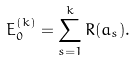<formula> <loc_0><loc_0><loc_500><loc_500>E _ { 0 } ^ { ( k ) } = \sum ^ { k } _ { s = 1 } R ( a _ { s } ) .</formula> 